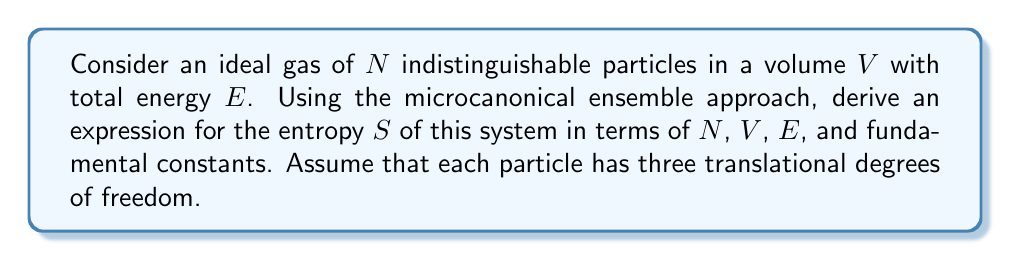Can you solve this math problem? Let's approach this step-by-step:

1) In the microcanonical ensemble, we start with the fundamental equation for entropy:

   $$S = k_B \ln \Omega(E,V,N)$$

   where $k_B$ is Boltzmann's constant and $\Omega$ is the number of microstates.

2) For an ideal gas, we can use the phase space volume to calculate $\Omega$. The phase space volume is:

   $$\Omega(E,V,N) = \frac{1}{h^{3N}N!} \int d^{3N}p d^{3N}q$$

   where $h$ is Planck's constant, and the integral is over all positions $q$ and momenta $p$ consistent with the total energy $E$.

3) The position integral is simply $V^N$. For the momentum integral, we use the fact that the energy of an ideal gas is purely kinetic:

   $$E = \sum_{i=1}^N \frac{p_i^2}{2m}$$

4) This defines a 3N-dimensional sphere in momentum space with radius $\sqrt{2mE}$. The volume of this sphere is:

   $$\frac{\pi^{3N/2}}{\Gamma(3N/2+1)}(2mE)^{3N/2}$$

5) Combining these results:

   $$\Omega(E,V,N) = \frac{1}{h^{3N}N!} V^N \frac{\pi^{3N/2}}{\Gamma(3N/2+1)}(2mE)^{3N/2}$$

6) Taking the natural logarithm and using Stirling's approximation for large $N$:

   $$\ln \Omega \approx N\ln V + \frac{3N}{2}\ln E + \frac{3N}{2}\ln(2\pi m) - N\ln N + N - \frac{3N}{2}\ln(3N/2) + \frac{3N}{2} - 3N\ln h$$

7) Multiplying by $k_B$ gives the entropy:

   $$S = k_B N \ln \left(\frac{V}{N}\left(\frac{4\pi mE}{3Nh^2}\right)^{3/2}\right) + \frac{5}{2}Nk_B$$

8) This can be rewritten in terms of the thermal wavelength $\lambda = h/\sqrt{2\pi mk_BT}$:

   $$S = Nk_B \ln \left(\frac{V}{N\lambda^3}\right) + \frac{5}{2}Nk_B$$

This is the Sackur-Tetrode equation for the entropy of an ideal gas.
Answer: $$S = Nk_B \ln \left(\frac{V}{N\lambda^3}\right) + \frac{5}{2}Nk_B$$ 